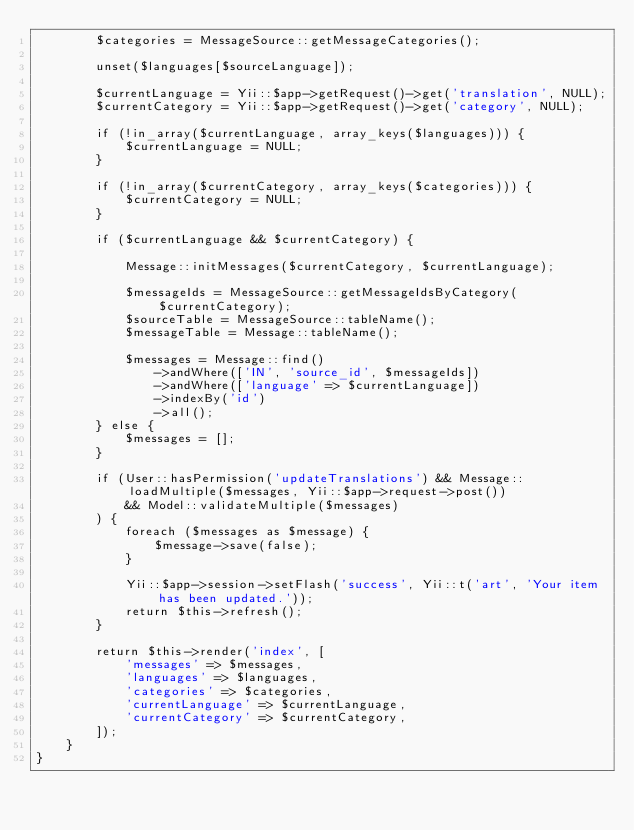Convert code to text. <code><loc_0><loc_0><loc_500><loc_500><_PHP_>        $categories = MessageSource::getMessageCategories();

        unset($languages[$sourceLanguage]);

        $currentLanguage = Yii::$app->getRequest()->get('translation', NULL);
        $currentCategory = Yii::$app->getRequest()->get('category', NULL);

        if (!in_array($currentLanguage, array_keys($languages))) {
            $currentLanguage = NULL;
        }

        if (!in_array($currentCategory, array_keys($categories))) {
            $currentCategory = NULL;
        }

        if ($currentLanguage && $currentCategory) {

            Message::initMessages($currentCategory, $currentLanguage);

            $messageIds = MessageSource::getMessageIdsByCategory($currentCategory);
            $sourceTable = MessageSource::tableName();
            $messageTable = Message::tableName();

            $messages = Message::find()
                ->andWhere(['IN', 'source_id', $messageIds])
                ->andWhere(['language' => $currentLanguage])
                ->indexBy('id')
                ->all();
        } else {
            $messages = [];
        }

        if (User::hasPermission('updateTranslations') && Message::loadMultiple($messages, Yii::$app->request->post())
            && Model::validateMultiple($messages)
        ) {
            foreach ($messages as $message) {
                $message->save(false);
            }

            Yii::$app->session->setFlash('success', Yii::t('art', 'Your item has been updated.'));
            return $this->refresh();
        }

        return $this->render('index', [
            'messages' => $messages,
            'languages' => $languages,
            'categories' => $categories,
            'currentLanguage' => $currentLanguage,
            'currentCategory' => $currentCategory,
        ]);
    }
}</code> 